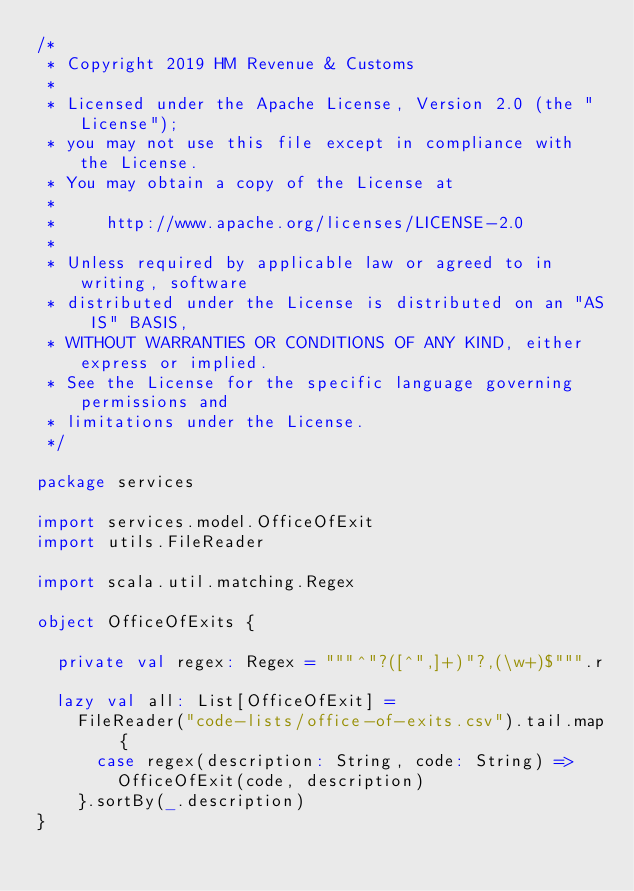<code> <loc_0><loc_0><loc_500><loc_500><_Scala_>/*
 * Copyright 2019 HM Revenue & Customs
 *
 * Licensed under the Apache License, Version 2.0 (the "License");
 * you may not use this file except in compliance with the License.
 * You may obtain a copy of the License at
 *
 *     http://www.apache.org/licenses/LICENSE-2.0
 *
 * Unless required by applicable law or agreed to in writing, software
 * distributed under the License is distributed on an "AS IS" BASIS,
 * WITHOUT WARRANTIES OR CONDITIONS OF ANY KIND, either express or implied.
 * See the License for the specific language governing permissions and
 * limitations under the License.
 */

package services

import services.model.OfficeOfExit
import utils.FileReader

import scala.util.matching.Regex

object OfficeOfExits {

  private val regex: Regex = """^"?([^",]+)"?,(\w+)$""".r

  lazy val all: List[OfficeOfExit] =
    FileReader("code-lists/office-of-exits.csv").tail.map {
      case regex(description: String, code: String) =>
        OfficeOfExit(code, description)
    }.sortBy(_.description)
}
</code> 